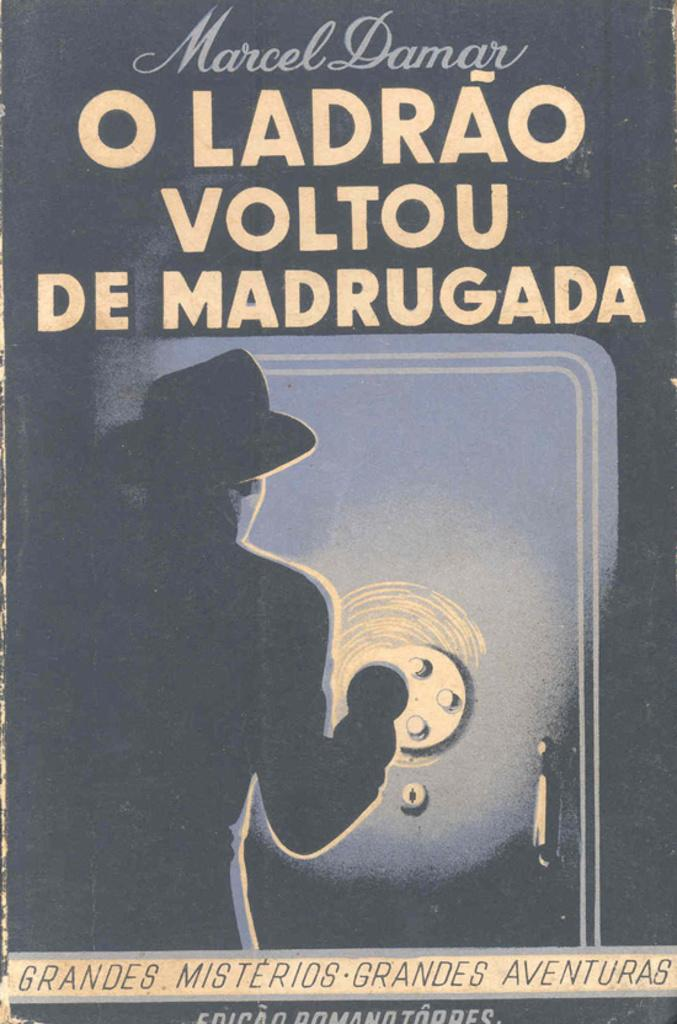<image>
Share a concise interpretation of the image provided. The mystery novel is written by Marcel Damar. 